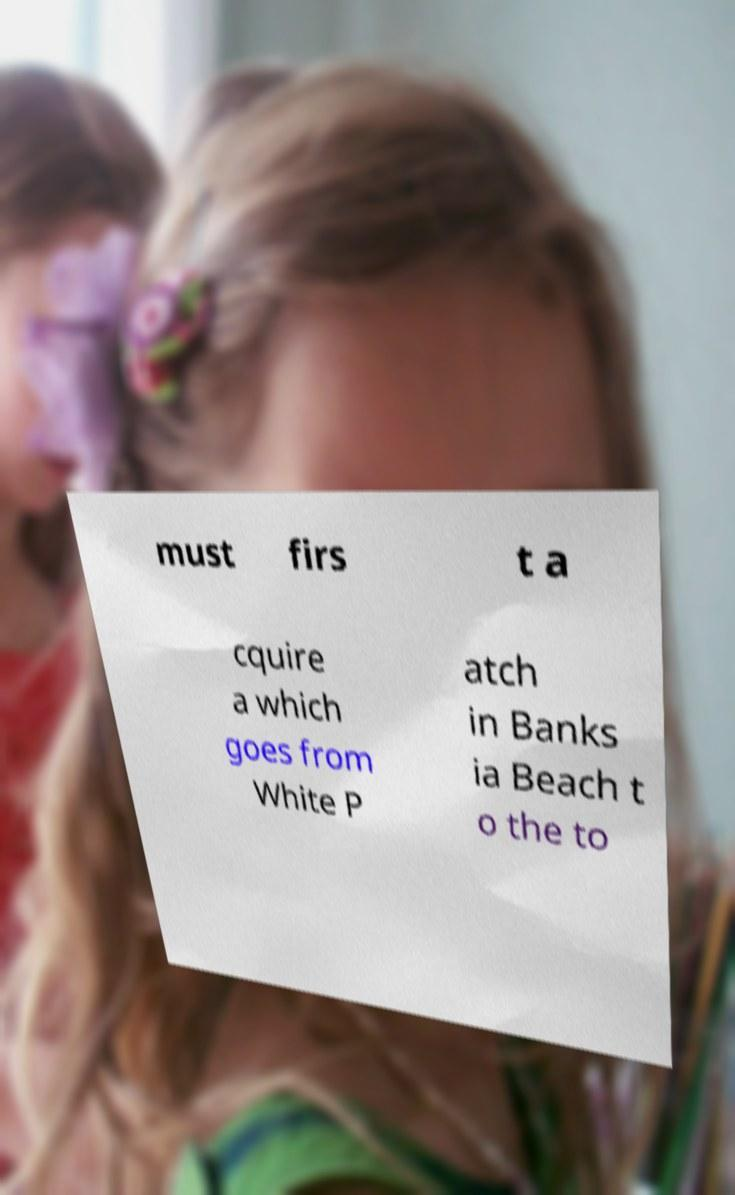I need the written content from this picture converted into text. Can you do that? must firs t a cquire a which goes from White P atch in Banks ia Beach t o the to 